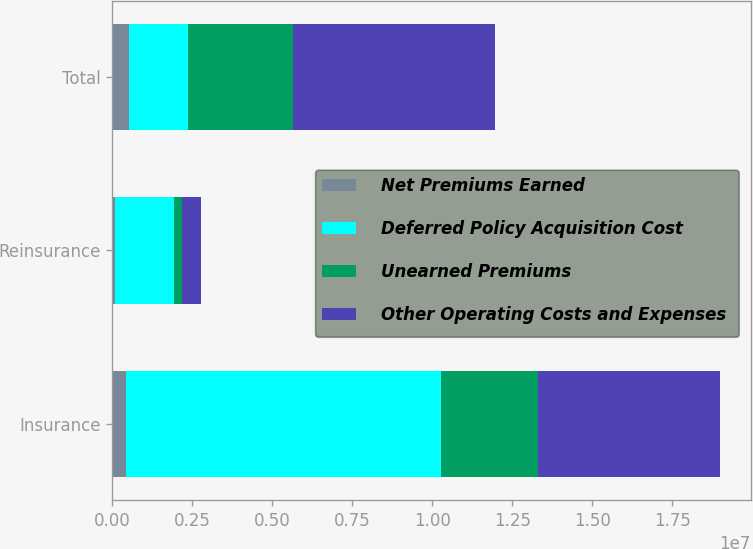Convert chart to OTSL. <chart><loc_0><loc_0><loc_500><loc_500><stacked_bar_chart><ecel><fcel>Insurance<fcel>Reinsurance<fcel>Total<nl><fcel>Net Premiums Earned<fcel>435967<fcel>71582<fcel>507549<nl><fcel>Deferred Policy Acquisition Cost<fcel>9.82026e+06<fcel>1.85015e+06<fcel>1.85015e+06<nl><fcel>Unearned Premiums<fcel>3.03934e+06<fcel>250837<fcel>3.29018e+06<nl><fcel>Other Operating Costs and Expenses<fcel>5.70644e+06<fcel>604976<fcel>6.31142e+06<nl></chart> 